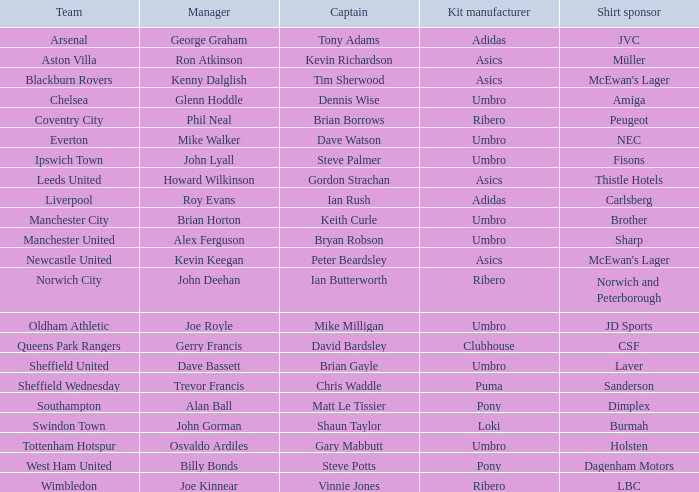Who is the manager in charge of the sheffield wednesday team? Trevor Francis. 